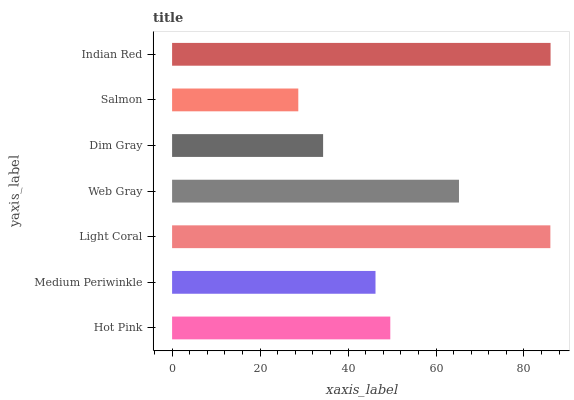Is Salmon the minimum?
Answer yes or no. Yes. Is Indian Red the maximum?
Answer yes or no. Yes. Is Medium Periwinkle the minimum?
Answer yes or no. No. Is Medium Periwinkle the maximum?
Answer yes or no. No. Is Hot Pink greater than Medium Periwinkle?
Answer yes or no. Yes. Is Medium Periwinkle less than Hot Pink?
Answer yes or no. Yes. Is Medium Periwinkle greater than Hot Pink?
Answer yes or no. No. Is Hot Pink less than Medium Periwinkle?
Answer yes or no. No. Is Hot Pink the high median?
Answer yes or no. Yes. Is Hot Pink the low median?
Answer yes or no. Yes. Is Salmon the high median?
Answer yes or no. No. Is Light Coral the low median?
Answer yes or no. No. 